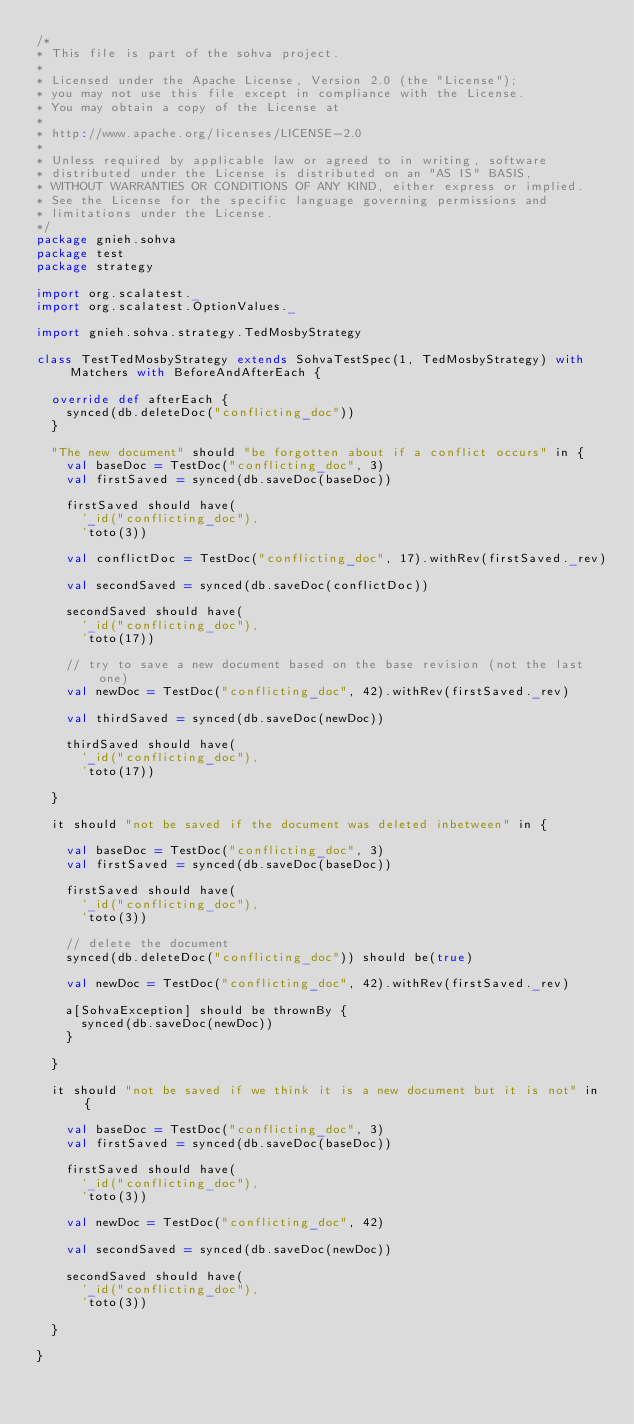Convert code to text. <code><loc_0><loc_0><loc_500><loc_500><_Scala_>/*
* This file is part of the sohva project.
*
* Licensed under the Apache License, Version 2.0 (the "License");
* you may not use this file except in compliance with the License.
* You may obtain a copy of the License at
*
* http://www.apache.org/licenses/LICENSE-2.0
*
* Unless required by applicable law or agreed to in writing, software
* distributed under the License is distributed on an "AS IS" BASIS,
* WITHOUT WARRANTIES OR CONDITIONS OF ANY KIND, either express or implied.
* See the License for the specific language governing permissions and
* limitations under the License.
*/
package gnieh.sohva
package test
package strategy

import org.scalatest._
import org.scalatest.OptionValues._

import gnieh.sohva.strategy.TedMosbyStrategy

class TestTedMosbyStrategy extends SohvaTestSpec(1, TedMosbyStrategy) with Matchers with BeforeAndAfterEach {

  override def afterEach {
    synced(db.deleteDoc("conflicting_doc"))
  }

  "The new document" should "be forgotten about if a conflict occurs" in {
    val baseDoc = TestDoc("conflicting_doc", 3)
    val firstSaved = synced(db.saveDoc(baseDoc))

    firstSaved should have(
      '_id("conflicting_doc"),
      'toto(3))

    val conflictDoc = TestDoc("conflicting_doc", 17).withRev(firstSaved._rev)

    val secondSaved = synced(db.saveDoc(conflictDoc))

    secondSaved should have(
      '_id("conflicting_doc"),
      'toto(17))

    // try to save a new document based on the base revision (not the last one)
    val newDoc = TestDoc("conflicting_doc", 42).withRev(firstSaved._rev)

    val thirdSaved = synced(db.saveDoc(newDoc))

    thirdSaved should have(
      '_id("conflicting_doc"),
      'toto(17))

  }

  it should "not be saved if the document was deleted inbetween" in {

    val baseDoc = TestDoc("conflicting_doc", 3)
    val firstSaved = synced(db.saveDoc(baseDoc))

    firstSaved should have(
      '_id("conflicting_doc"),
      'toto(3))

    // delete the document
    synced(db.deleteDoc("conflicting_doc")) should be(true)

    val newDoc = TestDoc("conflicting_doc", 42).withRev(firstSaved._rev)

    a[SohvaException] should be thrownBy {
      synced(db.saveDoc(newDoc))
    }

  }

  it should "not be saved if we think it is a new document but it is not" in {

    val baseDoc = TestDoc("conflicting_doc", 3)
    val firstSaved = synced(db.saveDoc(baseDoc))

    firstSaved should have(
      '_id("conflicting_doc"),
      'toto(3))

    val newDoc = TestDoc("conflicting_doc", 42)

    val secondSaved = synced(db.saveDoc(newDoc))

    secondSaved should have(
      '_id("conflicting_doc"),
      'toto(3))

  }

}
</code> 